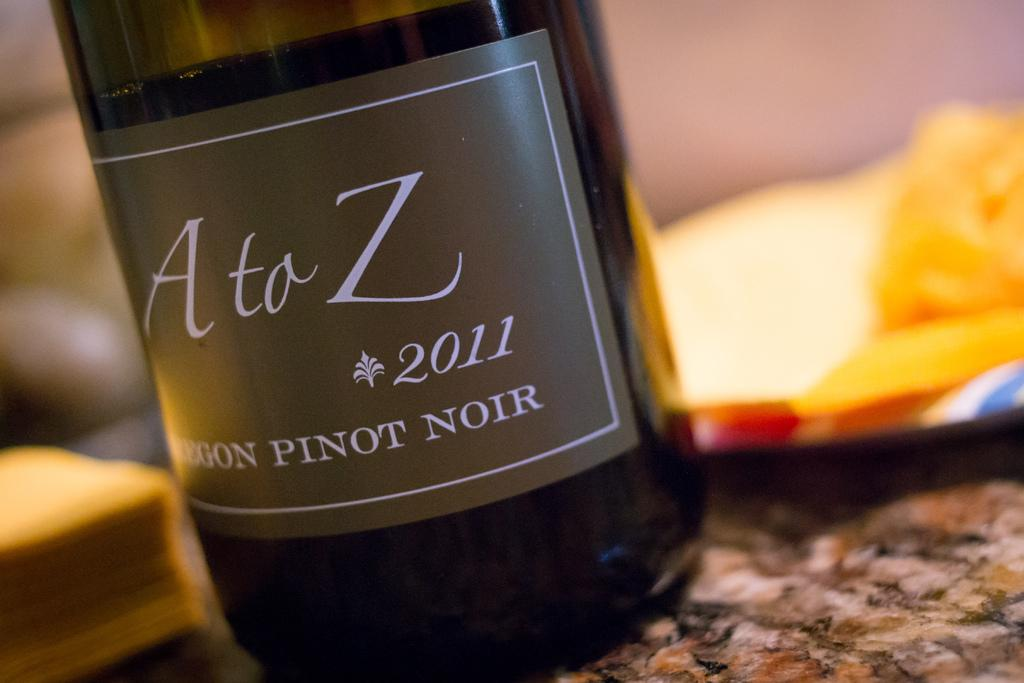<image>
Offer a succinct explanation of the picture presented. A bottle of Ata Z 2011 pinot noir. 